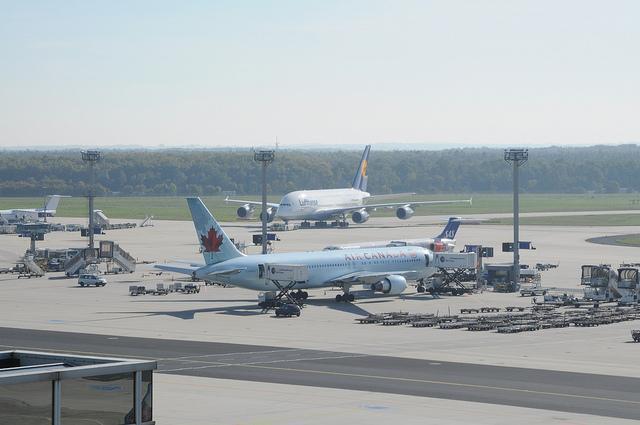How many planes are there?
Give a very brief answer. 3. How many planes are in the photo?
Give a very brief answer. 3. How many airplanes can be seen?
Give a very brief answer. 2. 